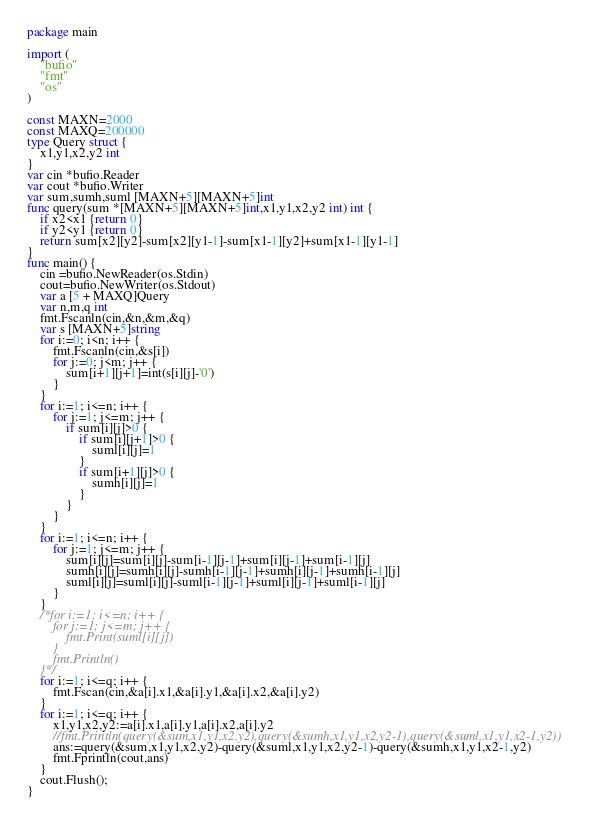<code> <loc_0><loc_0><loc_500><loc_500><_Go_>package main

import (
	"bufio"
	"fmt"
	"os"
)

const MAXN=2000
const MAXQ=200000
type Query struct {
	x1,y1,x2,y2 int
}
var cin *bufio.Reader
var cout *bufio.Writer
var sum,sumh,suml [MAXN+5][MAXN+5]int
func query(sum *[MAXN+5][MAXN+5]int,x1,y1,x2,y2 int) int {
	if x2<x1 {return 0}
	if y2<y1 {return 0}
	return sum[x2][y2]-sum[x2][y1-1]-sum[x1-1][y2]+sum[x1-1][y1-1]
}
func main() {
	cin =bufio.NewReader(os.Stdin)
	cout=bufio.NewWriter(os.Stdout)
	var a [5 + MAXQ]Query
	var n,m,q int
	fmt.Fscanln(cin,&n,&m,&q)
	var s [MAXN+5]string
	for i:=0; i<n; i++ {
		fmt.Fscanln(cin,&s[i])
		for j:=0; j<m; j++ {
			sum[i+1][j+1]=int(s[i][j]-'0')
		}
	}
	for i:=1; i<=n; i++ {
		for j:=1; j<=m; j++ {
			if sum[i][j]>0 {
				if sum[i][j+1]>0 {
					suml[i][j]=1
				}
				if sum[i+1][j]>0 {
					sumh[i][j]=1
				}
			}
		}
	}
	for i:=1; i<=n; i++ {
		for j:=1; j<=m; j++ {
			sum[i][j]=sum[i][j]-sum[i-1][j-1]+sum[i][j-1]+sum[i-1][j]
			sumh[i][j]=sumh[i][j]-sumh[i-1][j-1]+sumh[i][j-1]+sumh[i-1][j]
			suml[i][j]=suml[i][j]-suml[i-1][j-1]+suml[i][j-1]+suml[i-1][j]
		}
	}
	/*for i:=1; i<=n; i++ {
		for j:=1; j<=m; j++ {
			fmt.Print(suml[i][j])
		}
		fmt.Println()
	}*/
	for i:=1; i<=q; i++ {
		fmt.Fscan(cin,&a[i].x1,&a[i].y1,&a[i].x2,&a[i].y2)
	}
	for i:=1; i<=q; i++ {
		x1,y1,x2,y2:=a[i].x1,a[i].y1,a[i].x2,a[i].y2
		//fmt.Println(query(&sum,x1,y1,x2,y2),query(&sumh,x1,y1,x2,y2-1),query(&suml,x1,y1,x2-1,y2))
		ans:=query(&sum,x1,y1,x2,y2)-query(&suml,x1,y1,x2,y2-1)-query(&sumh,x1,y1,x2-1,y2)
		fmt.Fprintln(cout,ans)
	}
	cout.Flush();
}
</code> 